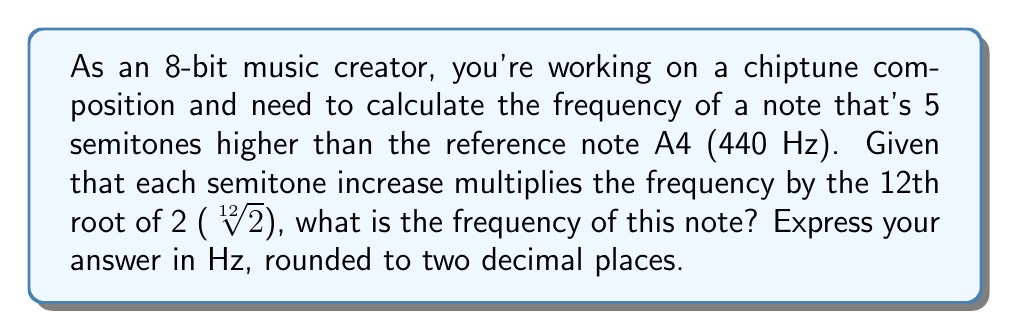Solve this math problem. To solve this problem, we'll use the following steps:

1) First, recall that the frequency ratio between two adjacent semitones is $\sqrt[12]{2}$.

2) Since our target note is 5 semitones higher than A4, we need to multiply the frequency of A4 by $(\sqrt[12]{2})^5$.

3) Let's express this mathematically:
   
   $f = 440 \cdot (\sqrt[12]{2})^5$

4) We can simplify the exponent:
   
   $f = 440 \cdot 2^{\frac{5}{12}}$

5) Now, let's calculate this:
   
   $f = 440 \cdot 2^{\frac{5}{12}}$
   $f = 440 \cdot 1.3348398541700344$
   $f = 587.3295398148152$

6) Rounding to two decimal places:
   
   $f \approx 587.33$ Hz

This frequency corresponds to the note D5 in the standard tuning system.
Answer: 587.33 Hz 